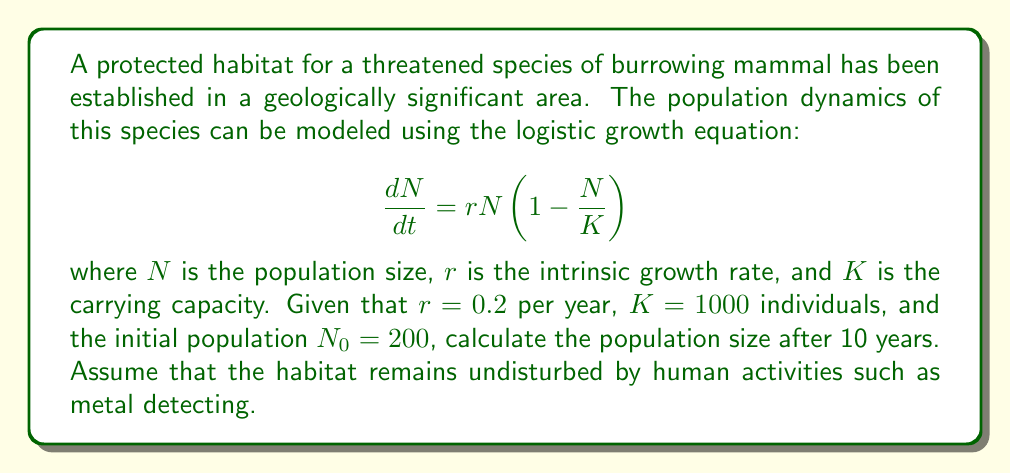Can you solve this math problem? To solve this problem, we need to use the analytical solution of the logistic growth equation, which is given by:

$$N(t) = \frac{KN_0e^{rt}}{K + N_0(e^{rt} - 1)}$$

where $N(t)$ is the population size at time $t$.

Given:
- $r = 0.2$ per year
- $K = 1000$ individuals
- $N_0 = 200$ individuals
- $t = 10$ years

Let's substitute these values into the equation:

$$N(10) = \frac{1000 \cdot 200 \cdot e^{0.2 \cdot 10}}{1000 + 200(e^{0.2 \cdot 10} - 1)}$$

Now, let's solve this step-by-step:

1. Calculate $e^{0.2 \cdot 10}$:
   $e^{0.2 \cdot 10} = e^2 \approx 7.3891$

2. Substitute this value into the numerator and denominator:
   $$N(10) = \frac{1000 \cdot 200 \cdot 7.3891}{1000 + 200(7.3891 - 1)}$$

3. Simplify:
   $$N(10) = \frac{1,477,820}{1000 + 1277.82}$$
   $$N(10) = \frac{1,477,820}{2277.82}$$

4. Divide:
   $$N(10) \approx 648.79$$

5. Round to the nearest whole number, as we're dealing with a population of individuals:
   $$N(10) \approx 649$$
Answer: The population size after 10 years will be approximately 649 individuals. 